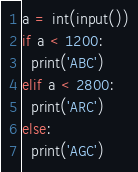Convert code to text. <code><loc_0><loc_0><loc_500><loc_500><_Python_>a = int(input())
if a < 1200:
  print('ABC')
elif a < 2800:
  print('ARC')
else:
  print('AGC')</code> 